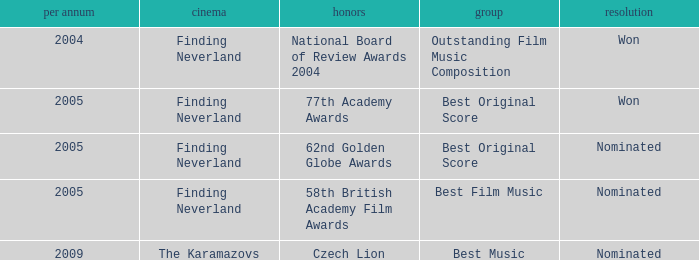How many years were there for the 62nd golden globe awards? 2005.0. 